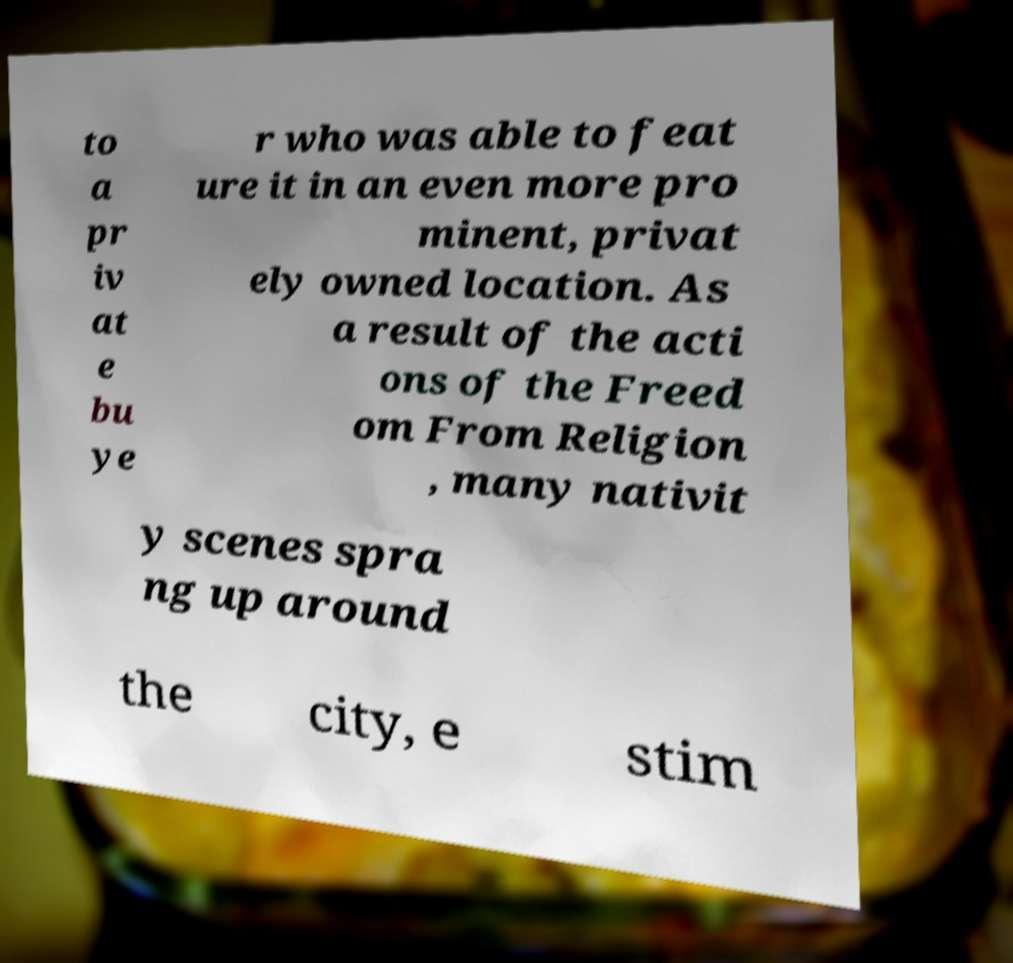Could you assist in decoding the text presented in this image and type it out clearly? to a pr iv at e bu ye r who was able to feat ure it in an even more pro minent, privat ely owned location. As a result of the acti ons of the Freed om From Religion , many nativit y scenes spra ng up around the city, e stim 